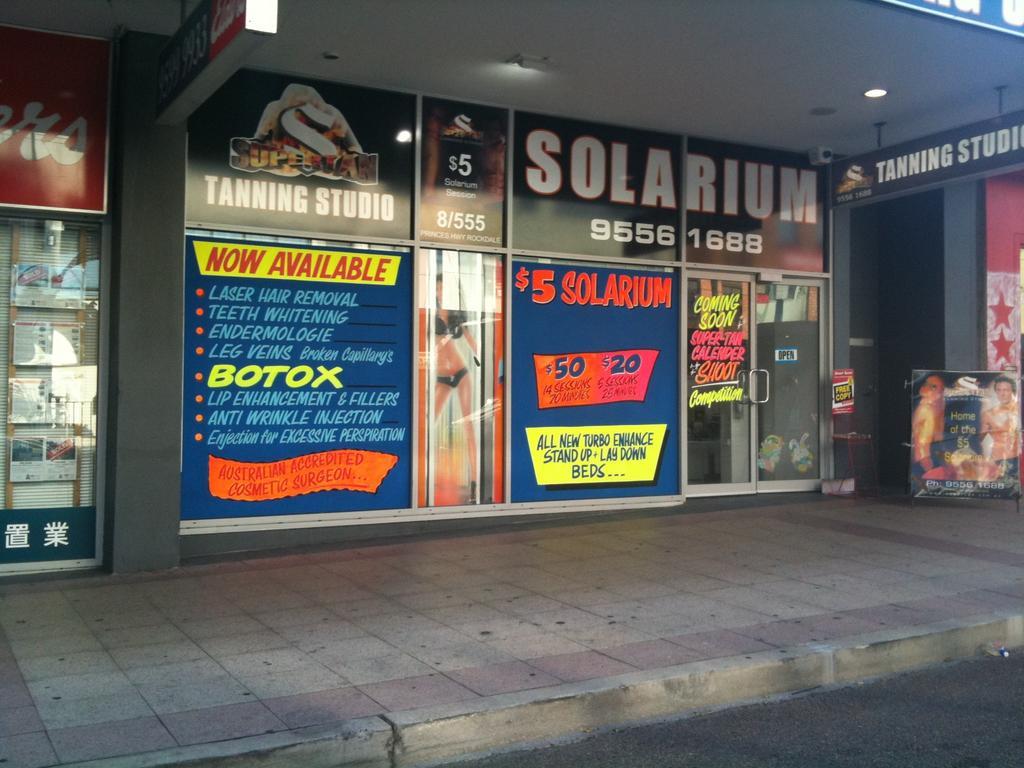Can you describe this image briefly? In this picture there is a building and there are boards on the building and there is text on the boards and there is a picture of a woman standing on the board. On the right side of the image there is a picture of a man on the board. At the top there are lights. At the bottom there is a footpath and there is a road. On the left side of the image it looks like a window blind behind the glass. 